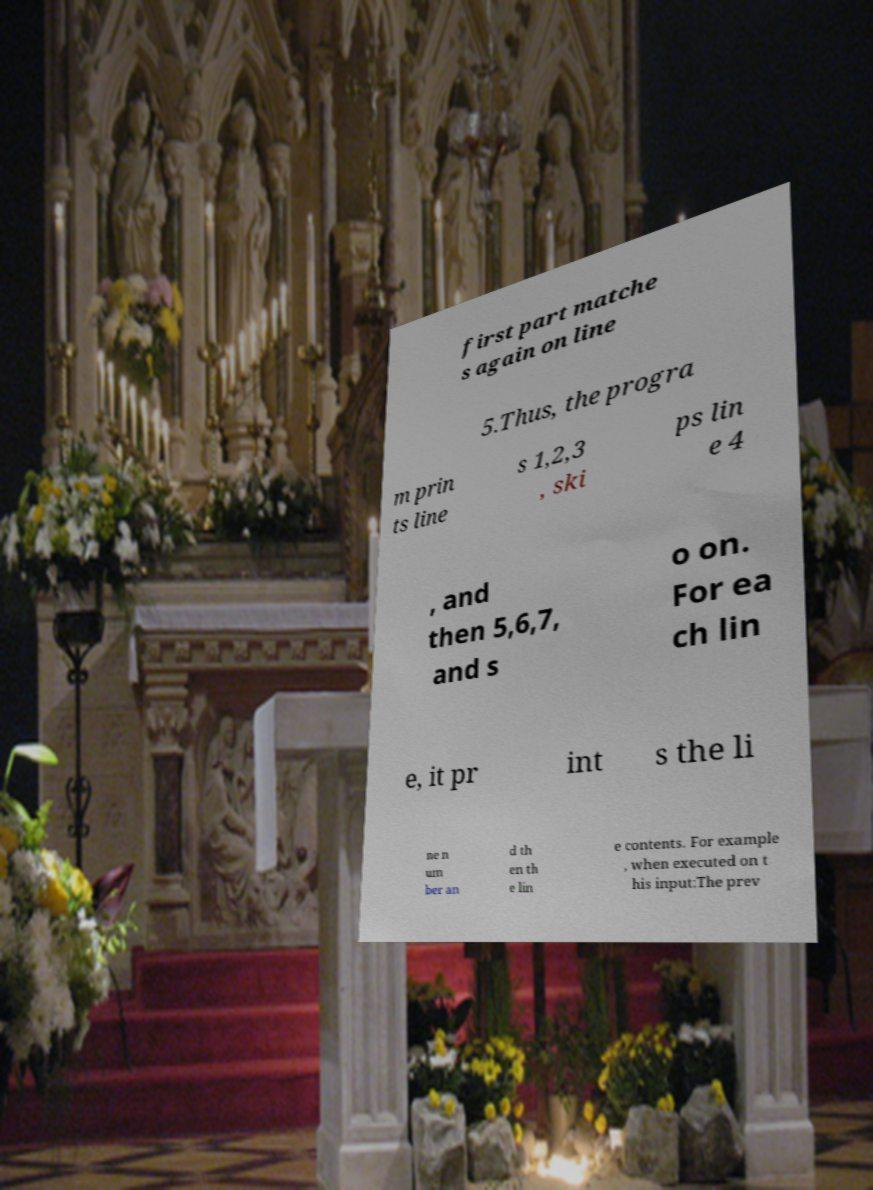Could you extract and type out the text from this image? first part matche s again on line 5.Thus, the progra m prin ts line s 1,2,3 , ski ps lin e 4 , and then 5,6,7, and s o on. For ea ch lin e, it pr int s the li ne n um ber an d th en th e lin e contents. For example , when executed on t his input:The prev 